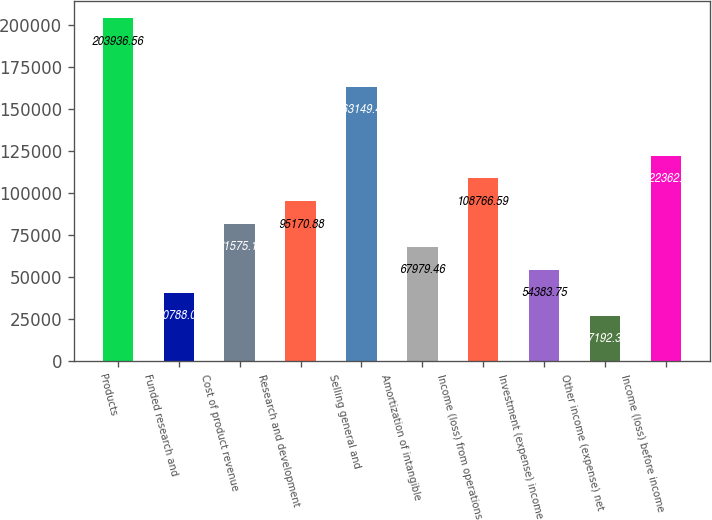Convert chart to OTSL. <chart><loc_0><loc_0><loc_500><loc_500><bar_chart><fcel>Products<fcel>Funded research and<fcel>Cost of product revenue<fcel>Research and development<fcel>Selling general and<fcel>Amortization of intangible<fcel>Income (loss) from operations<fcel>Investment (expense) income<fcel>Other income (expense) net<fcel>Income (loss) before income<nl><fcel>203937<fcel>40788<fcel>81575.2<fcel>95170.9<fcel>163149<fcel>67979.5<fcel>108767<fcel>54383.8<fcel>27192.3<fcel>122362<nl></chart> 